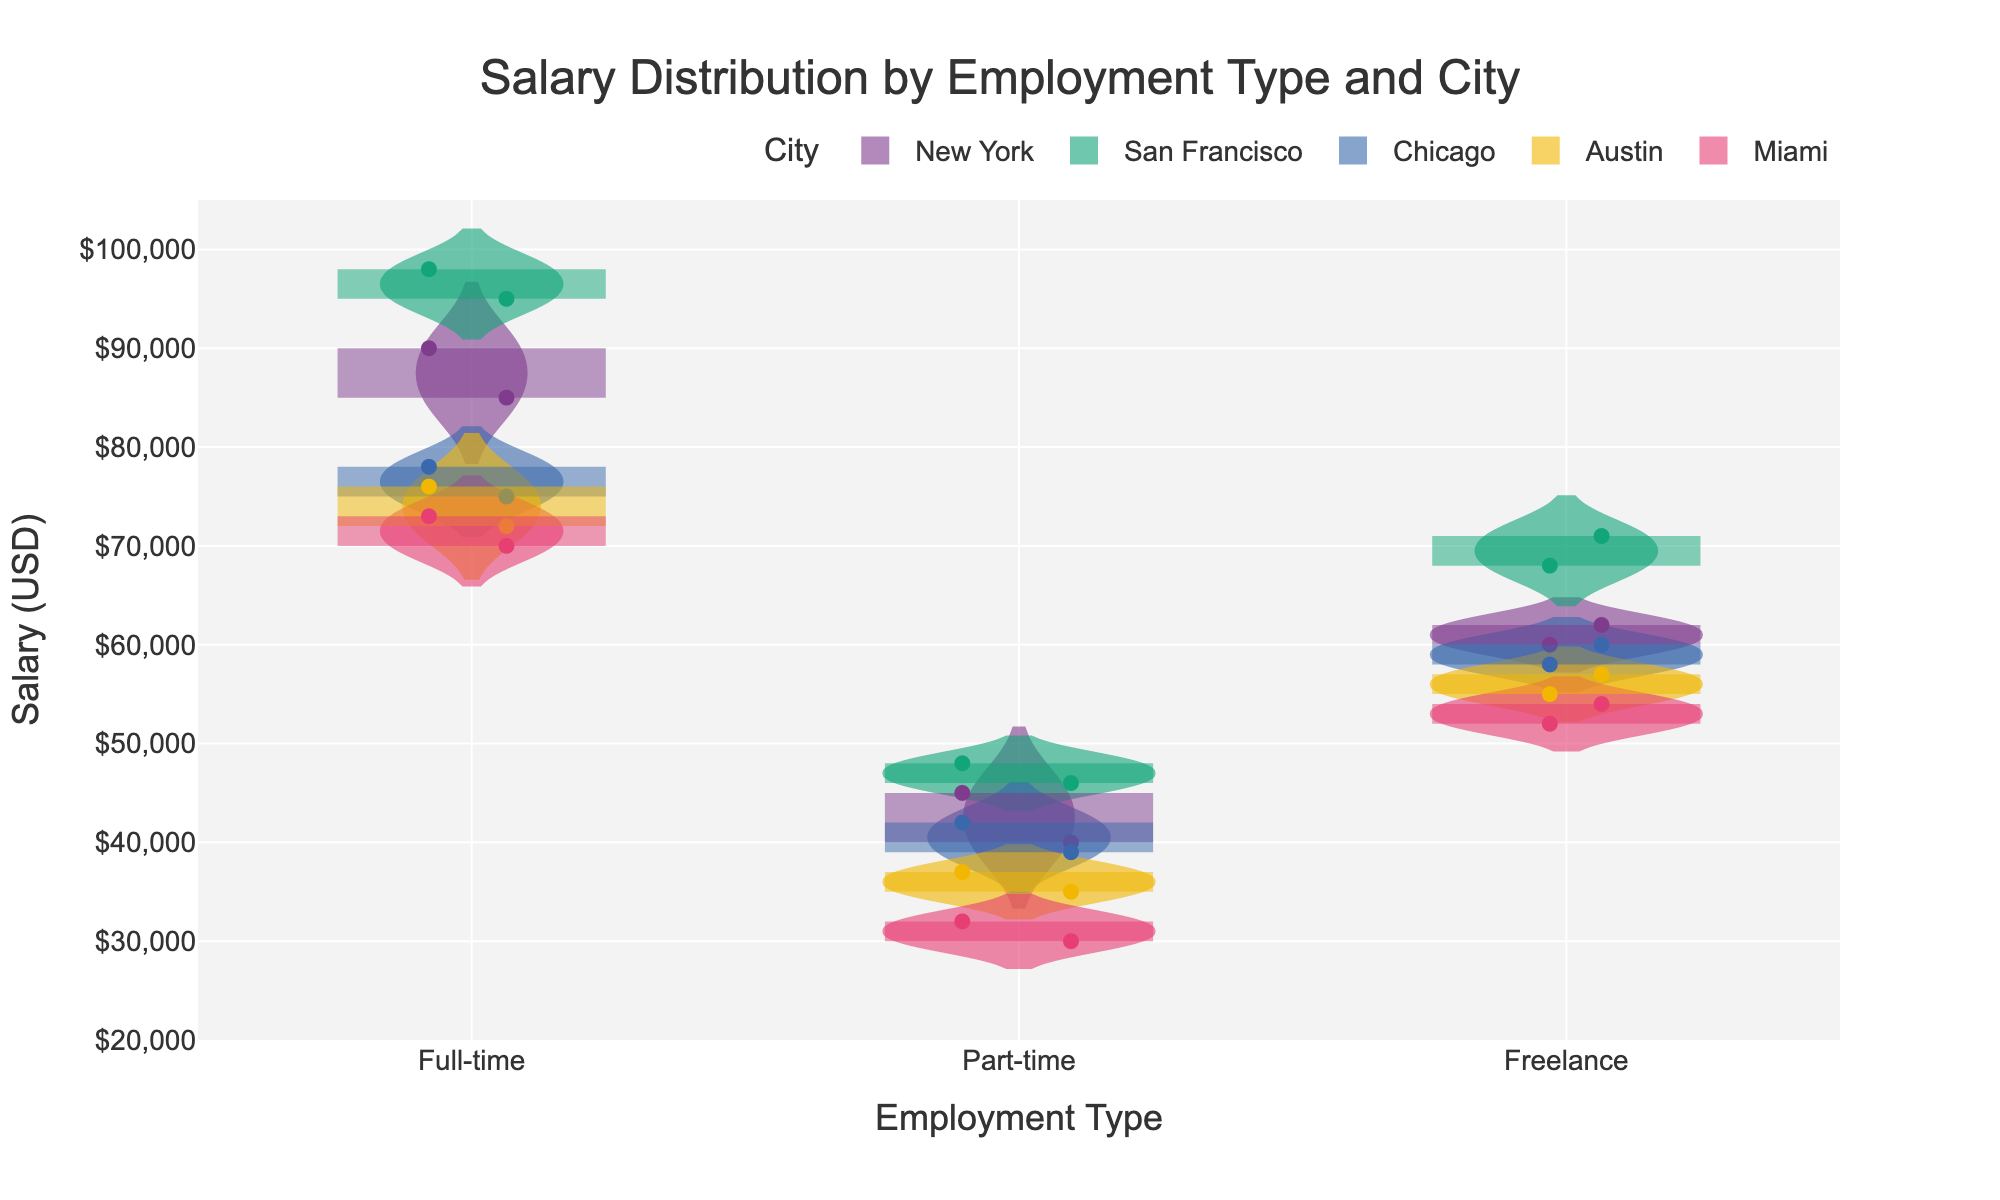What's the title of the figure? The title of a figure is usually located at the top. In this plot, the title is clearly stated there.
Answer: Salary Distribution by Employment Type and City What are the x-axis and y-axis labels? The x-axis and y-axis labels describe what each axis represents. Here, the x-axis label is "Employment Type" and the y-axis label is "Salary (USD)"
Answer: Employment Type, Salary (USD) Which city has the highest average salary for full-time employment? To answer this, look at the violin plots for each city under the "Full-time" category and identify the highest average salary denoted by the line within the violin plot.
Answer: San Francisco What is the approximate salary range for part-time employment in Chicago? Examine the range of the violin plot for part-time employment in Chicago, which extends from the lowest to the highest data points.
Answer: $39,000 - $42,000 Compare the median salaries of freelance workers in New York and San Francisco. Which is higher? The median salary is indicated by the line inside the box plot within the violin plot. Compare these medians for New York and San Francisco.
Answer: San Francisco Which employment type in Austin has the widest salary distribution? The width of a violin plot indicates the spread of the data. Look for the employment type with the widest plot in Austin.
Answer: Full-time How does the freelance salary range in Miami compare to that in Austin? Look at the ranges of the violin plots for freelance workers in both Miami and Austin and compare their spreads.
Answer: Miami has a lower range Are there any overlapping salary ranges between full-time and part-time employment in New York? Check the two violin plots for full-time and part-time employment in New York to see if there are any areas where the salary ranges overlap.
Answer: No What range represents the middle 50% of salaries for full-time workers in San Francisco? The middle 50% is shown by the box within the violin plot. Look at the box to determine this range for full-time workers in San Francisco.
Answer: $95,000 - $98,000 Between which salary ranges do most part-time employees in Miami fall? The density of the violin plot indicates where most data points are concentrated. Observe the part-time employment violin plot for Miami and the densest region.
Answer: $30,000 - $32,000 